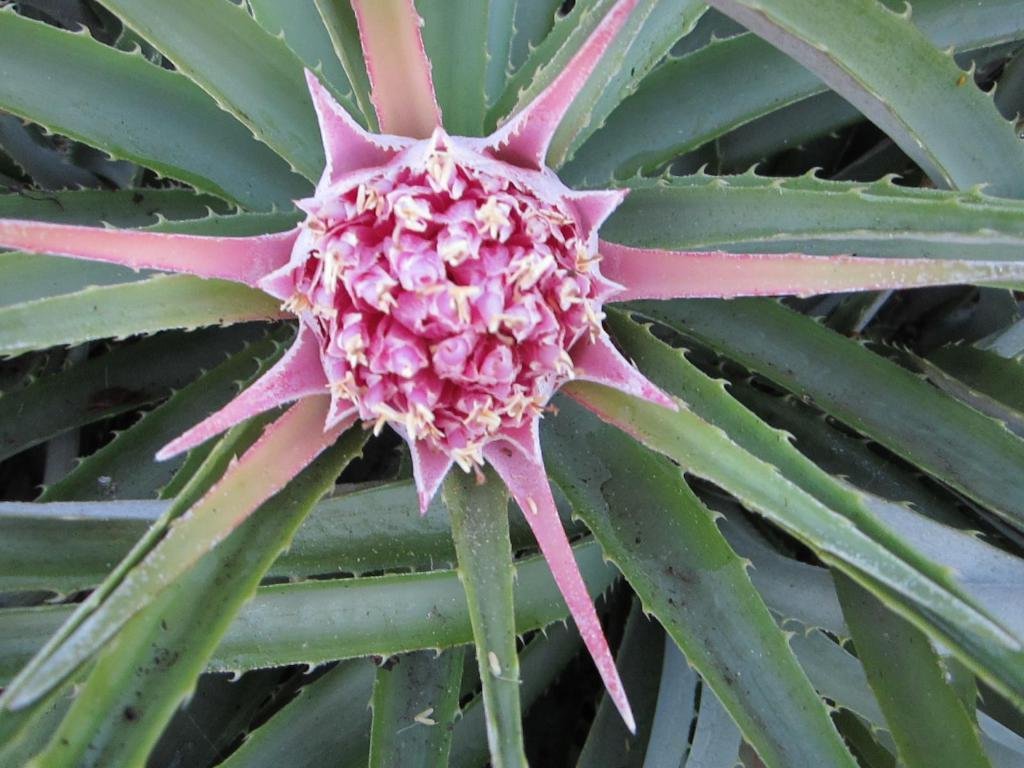What type of plant is visible in the image? There is a flower in the image. What colors can be seen on the flower? The flower has cream and pink colors. What other plant-related object is present in the image? There is a plant in the image. What color is the plant? The plant has a green color. What type of lamp is used to illuminate the flower in the image? There is no lamp present in the image. 